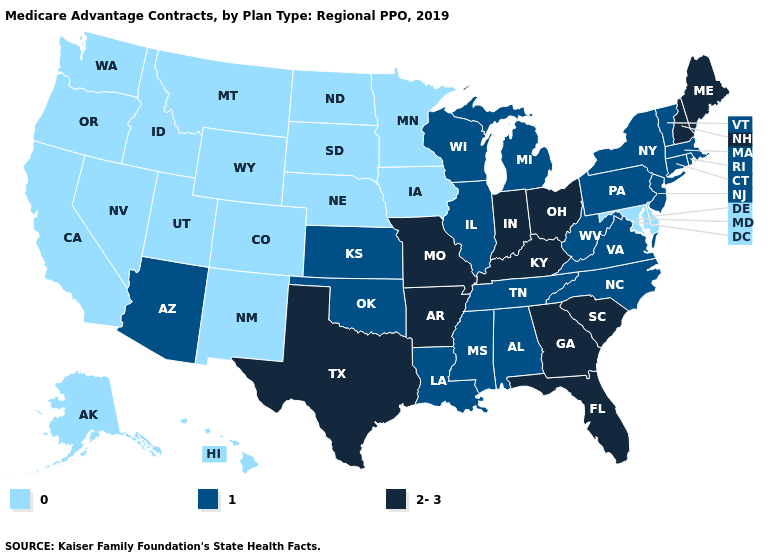What is the value of West Virginia?
Be succinct. 1. Does Montana have the lowest value in the USA?
Write a very short answer. Yes. Which states have the highest value in the USA?
Write a very short answer. Arkansas, Florida, Georgia, Indiana, Kentucky, Maine, Missouri, New Hampshire, Ohio, South Carolina, Texas. Name the states that have a value in the range 1?
Answer briefly. Alabama, Arizona, Connecticut, Illinois, Kansas, Louisiana, Massachusetts, Michigan, Mississippi, New Jersey, New York, North Carolina, Oklahoma, Pennsylvania, Rhode Island, Tennessee, Vermont, Virginia, West Virginia, Wisconsin. Which states have the lowest value in the USA?
Keep it brief. Alaska, California, Colorado, Delaware, Hawaii, Idaho, Iowa, Maryland, Minnesota, Montana, Nebraska, Nevada, New Mexico, North Dakota, Oregon, South Dakota, Utah, Washington, Wyoming. What is the value of South Carolina?
Keep it brief. 2-3. Does Alaska have a lower value than Wyoming?
Concise answer only. No. What is the value of Washington?
Answer briefly. 0. Does Florida have a higher value than North Dakota?
Quick response, please. Yes. Does the map have missing data?
Write a very short answer. No. Among the states that border Louisiana , does Mississippi have the lowest value?
Be succinct. Yes. Does Indiana have the lowest value in the USA?
Short answer required. No. Does Minnesota have a lower value than California?
Keep it brief. No. 